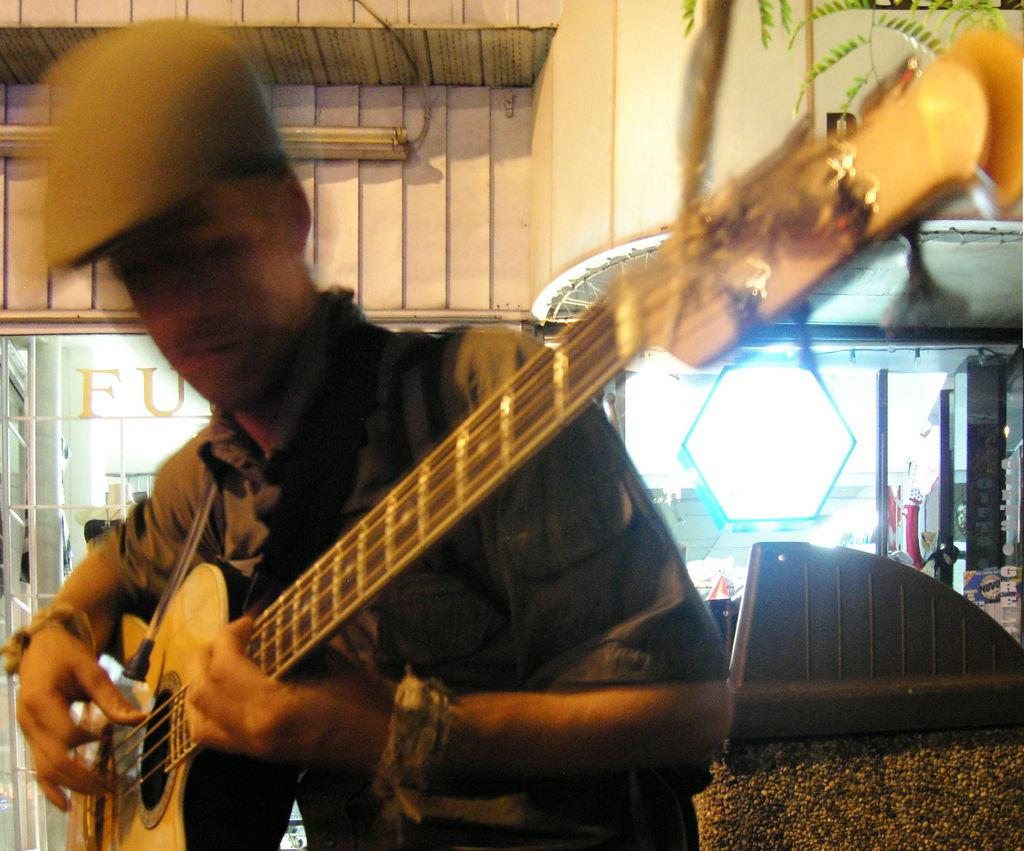What is the main subject of the image? There is a man in the image. What is the man holding in the image? The man is holding a guitar. How many bridges can be seen in the image? There are no bridges present in the image; it features a man holding a guitar. What type of bit is the man using to play the guitar in the image? There is no bit present in the image, as guitars are typically played with fingers or a guitar pick. 